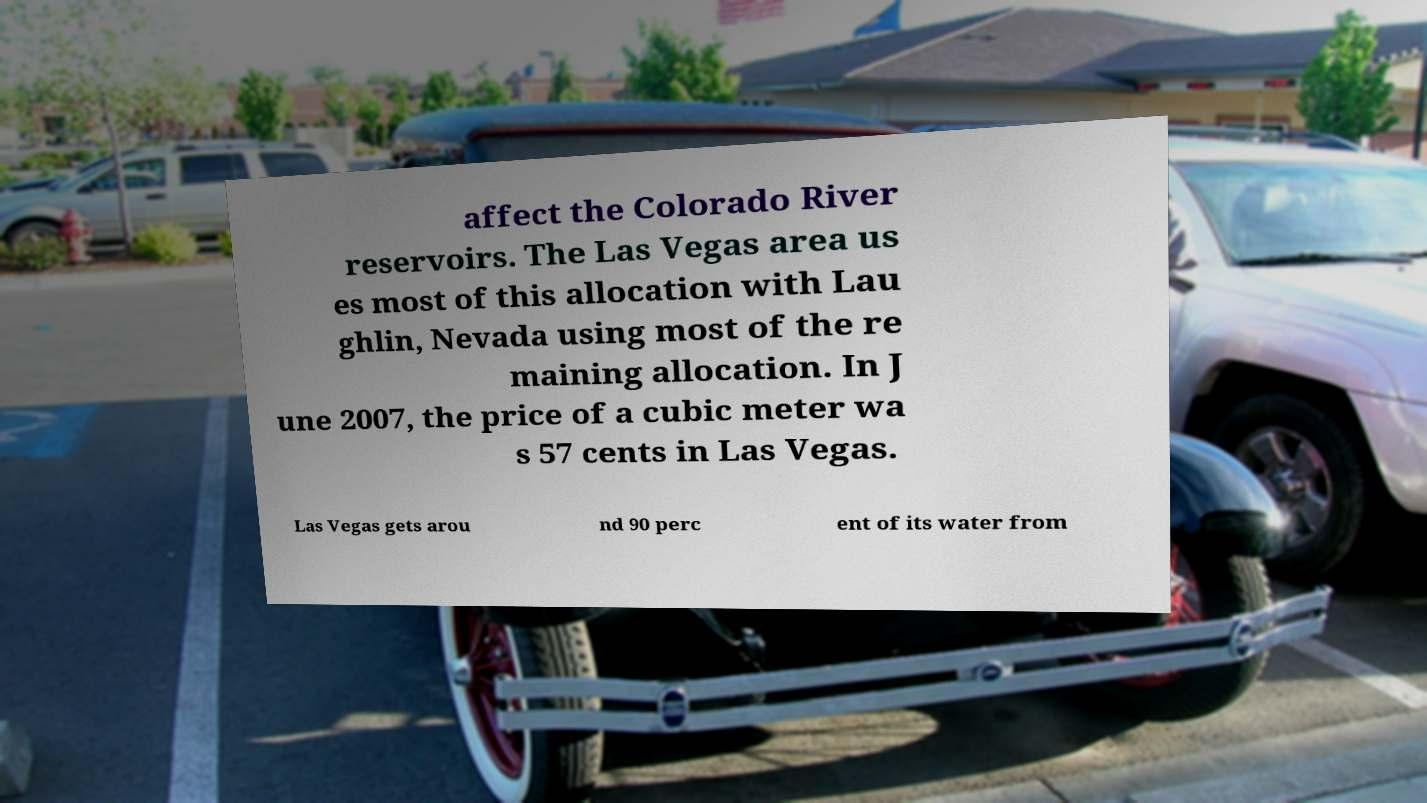Could you assist in decoding the text presented in this image and type it out clearly? affect the Colorado River reservoirs. The Las Vegas area us es most of this allocation with Lau ghlin, Nevada using most of the re maining allocation. In J une 2007, the price of a cubic meter wa s 57 cents in Las Vegas. Las Vegas gets arou nd 90 perc ent of its water from 